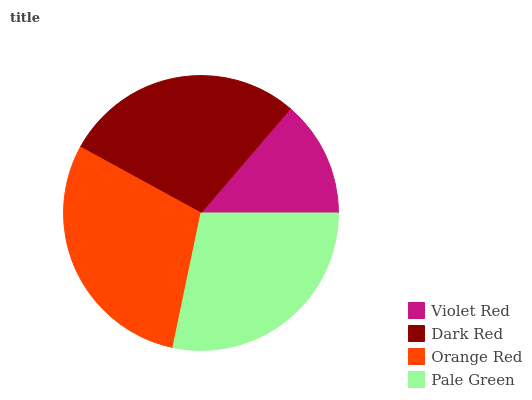Is Violet Red the minimum?
Answer yes or no. Yes. Is Orange Red the maximum?
Answer yes or no. Yes. Is Dark Red the minimum?
Answer yes or no. No. Is Dark Red the maximum?
Answer yes or no. No. Is Dark Red greater than Violet Red?
Answer yes or no. Yes. Is Violet Red less than Dark Red?
Answer yes or no. Yes. Is Violet Red greater than Dark Red?
Answer yes or no. No. Is Dark Red less than Violet Red?
Answer yes or no. No. Is Dark Red the high median?
Answer yes or no. Yes. Is Pale Green the low median?
Answer yes or no. Yes. Is Orange Red the high median?
Answer yes or no. No. Is Orange Red the low median?
Answer yes or no. No. 